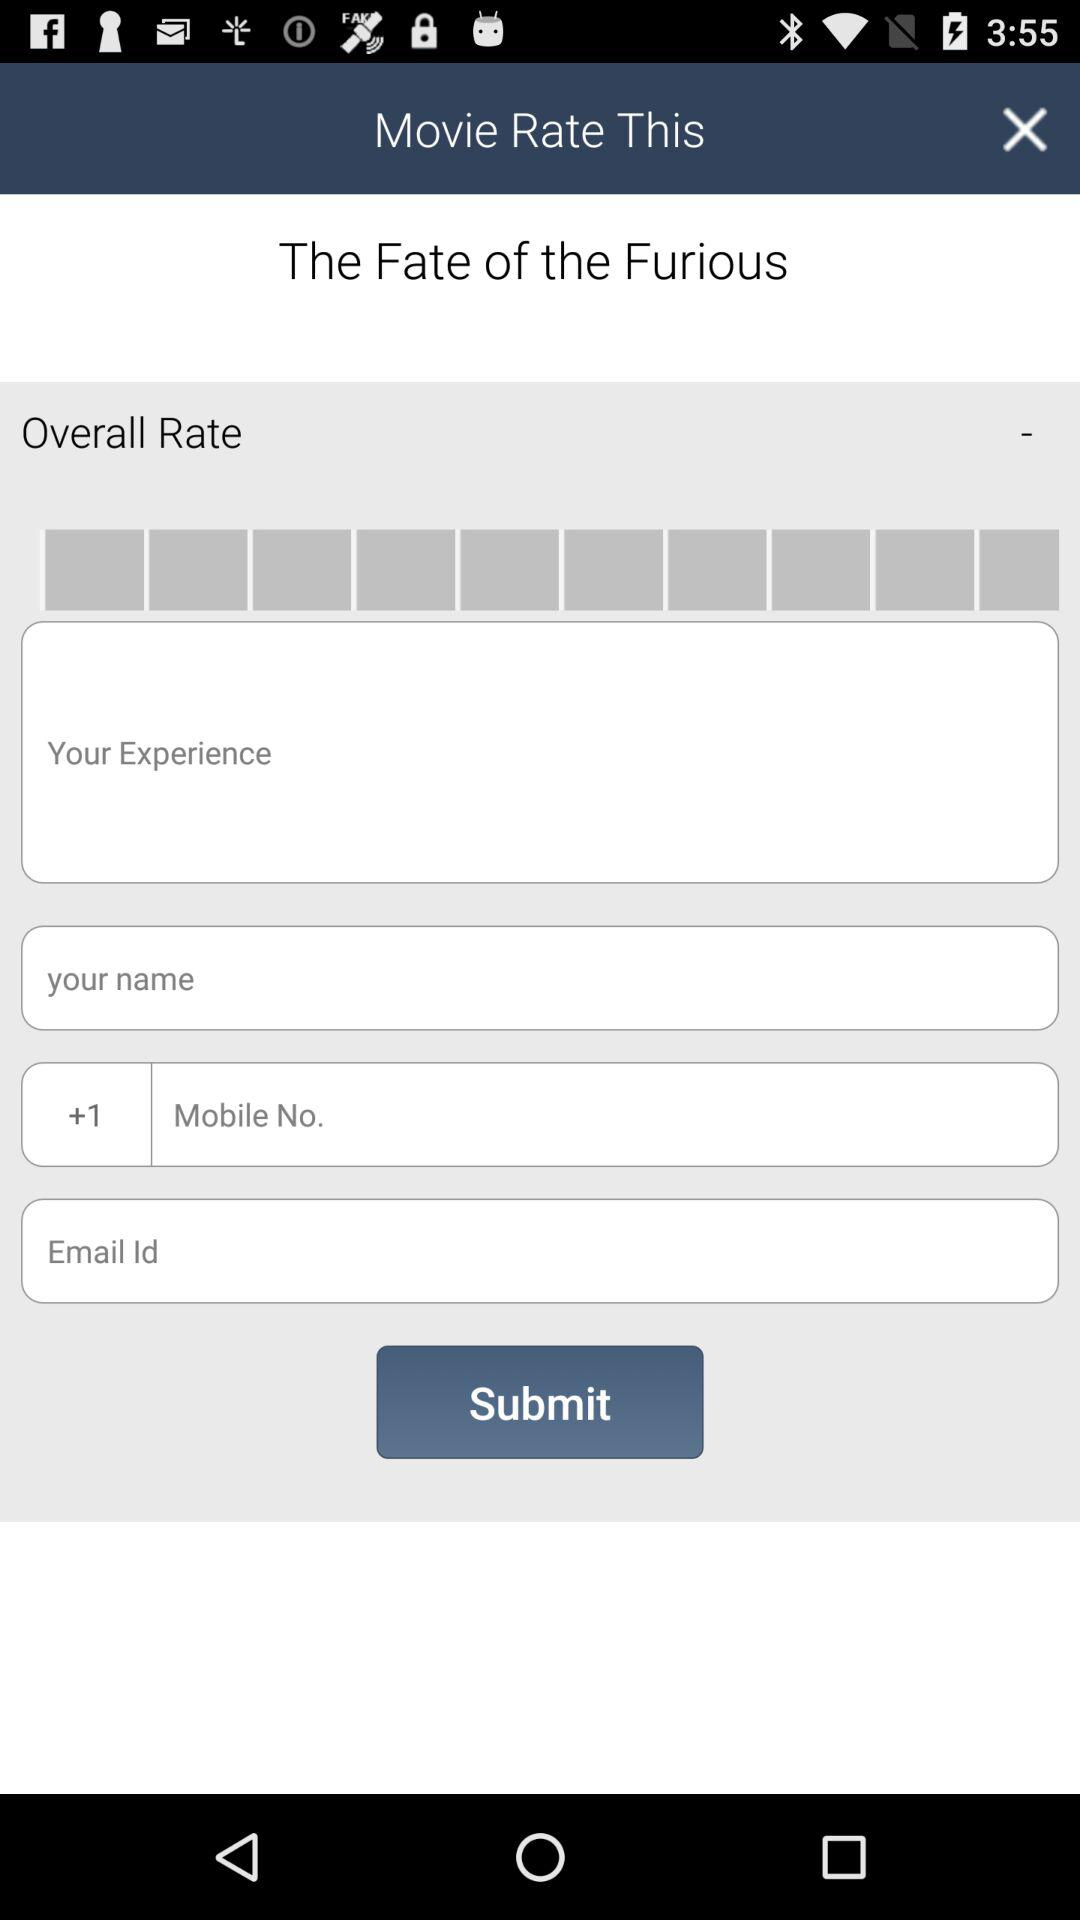What is the application name?
When the provided information is insufficient, respond with <no answer>. <no answer> 